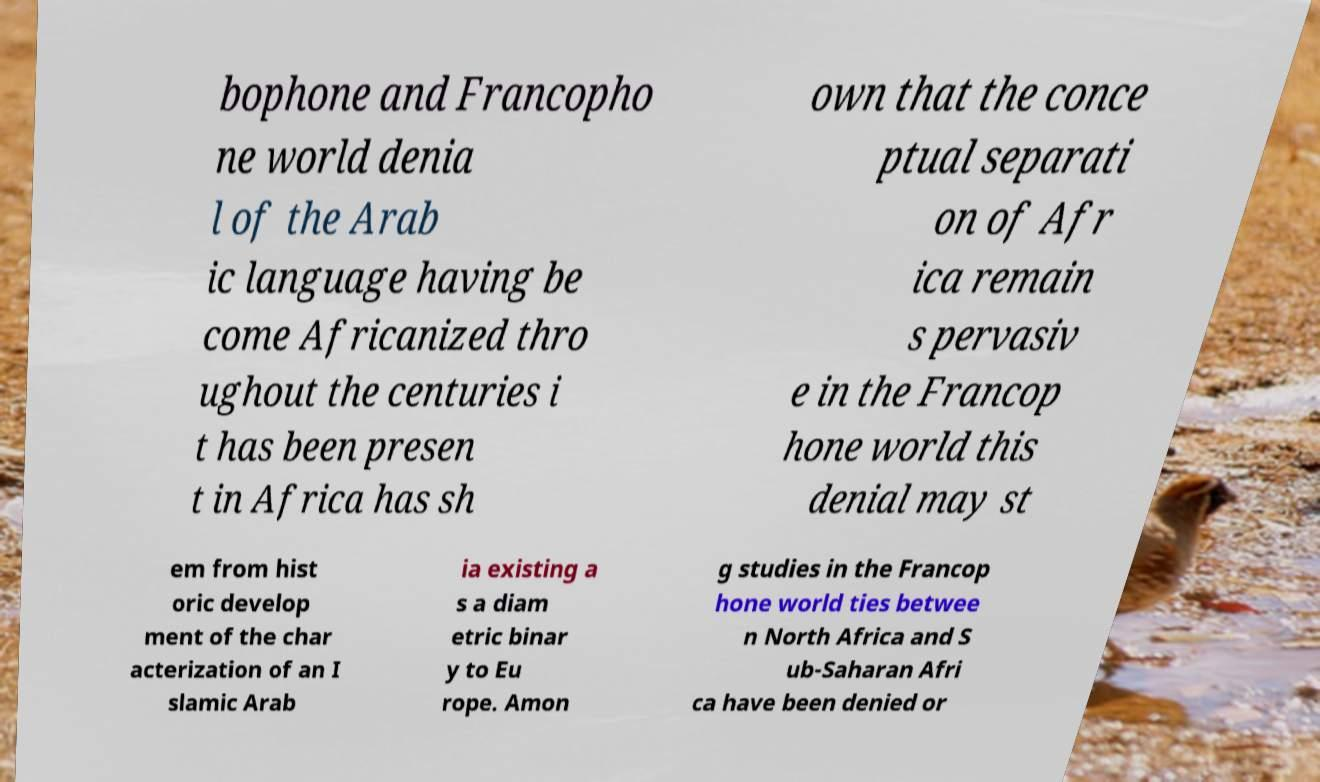Could you assist in decoding the text presented in this image and type it out clearly? bophone and Francopho ne world denia l of the Arab ic language having be come Africanized thro ughout the centuries i t has been presen t in Africa has sh own that the conce ptual separati on of Afr ica remain s pervasiv e in the Francop hone world this denial may st em from hist oric develop ment of the char acterization of an I slamic Arab ia existing a s a diam etric binar y to Eu rope. Amon g studies in the Francop hone world ties betwee n North Africa and S ub-Saharan Afri ca have been denied or 